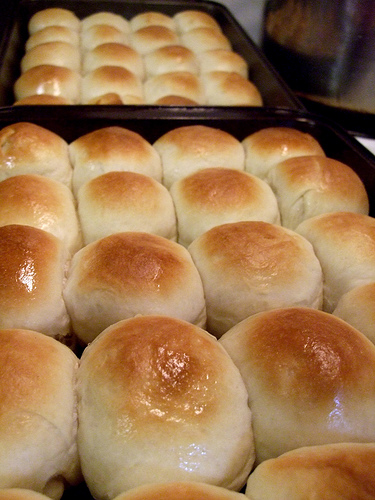<image>
Can you confirm if the baked bun is in front of the baking sheet? Yes. The baked bun is positioned in front of the baking sheet, appearing closer to the camera viewpoint. 